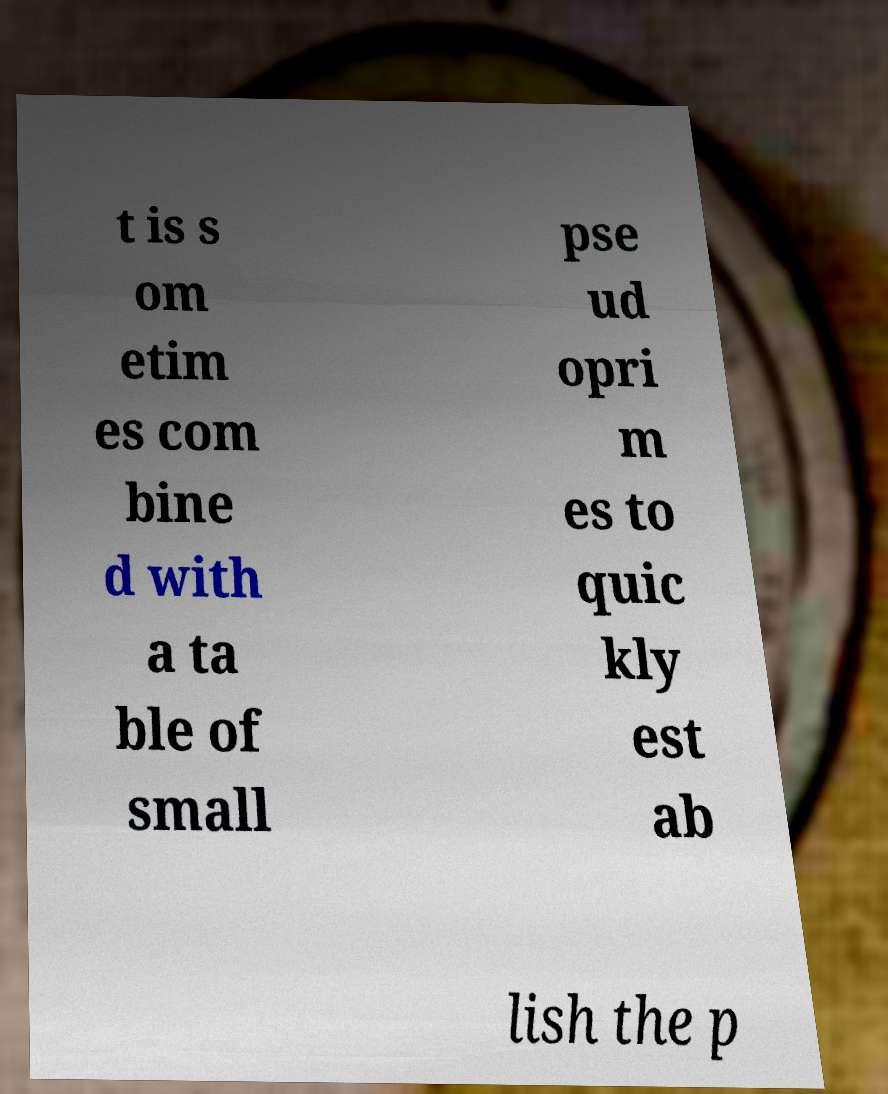I need the written content from this picture converted into text. Can you do that? t is s om etim es com bine d with a ta ble of small pse ud opri m es to quic kly est ab lish the p 